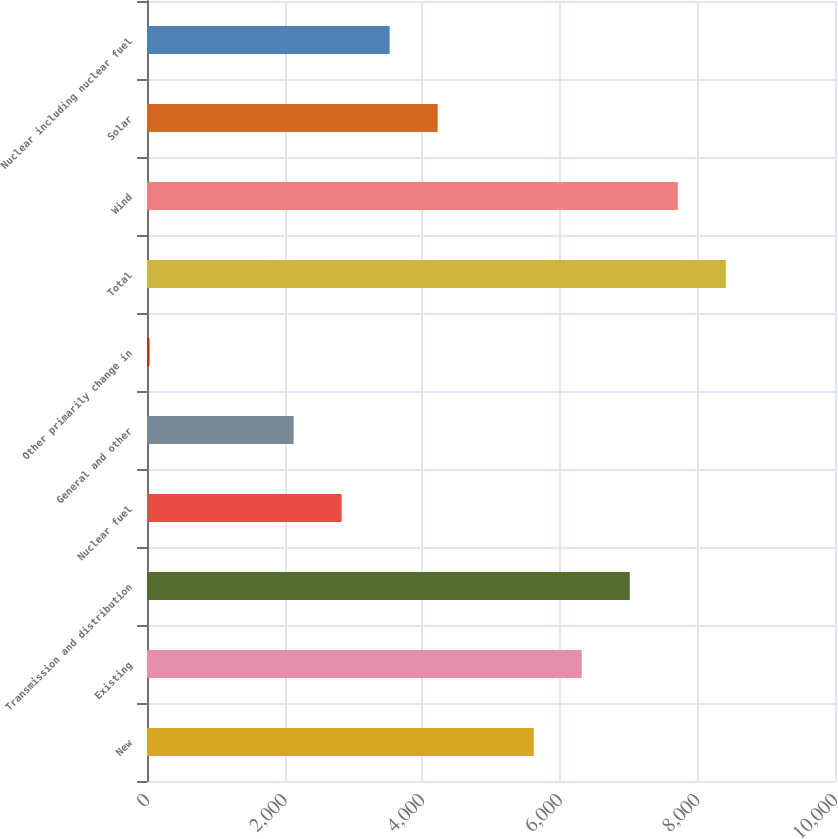Convert chart to OTSL. <chart><loc_0><loc_0><loc_500><loc_500><bar_chart><fcel>New<fcel>Existing<fcel>Transmission and distribution<fcel>Nuclear fuel<fcel>General and other<fcel>Other primarily change in<fcel>Total<fcel>Wind<fcel>Solar<fcel>Nuclear including nuclear fuel<nl><fcel>5621<fcel>6319<fcel>7017<fcel>2829<fcel>2131<fcel>37<fcel>8413<fcel>7715<fcel>4225<fcel>3527<nl></chart> 